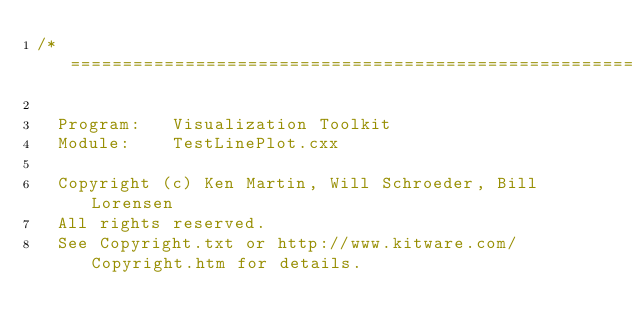Convert code to text. <code><loc_0><loc_0><loc_500><loc_500><_C++_>/*=========================================================================

  Program:   Visualization Toolkit
  Module:    TestLinePlot.cxx

  Copyright (c) Ken Martin, Will Schroeder, Bill Lorensen
  All rights reserved.
  See Copyright.txt or http://www.kitware.com/Copyright.htm for details.
</code> 